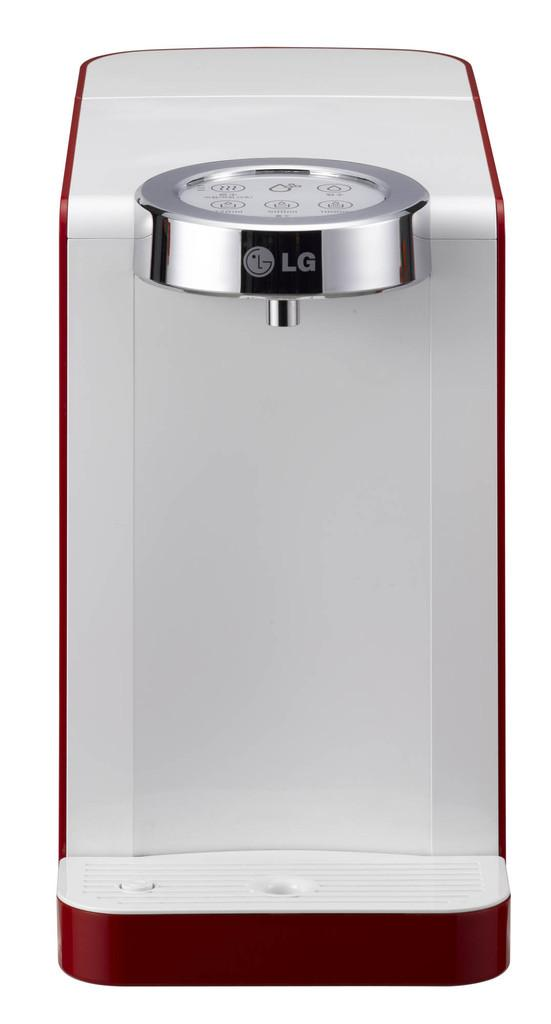<image>
Present a compact description of the photo's key features. A silver and red LG water dispenser on a white background. 